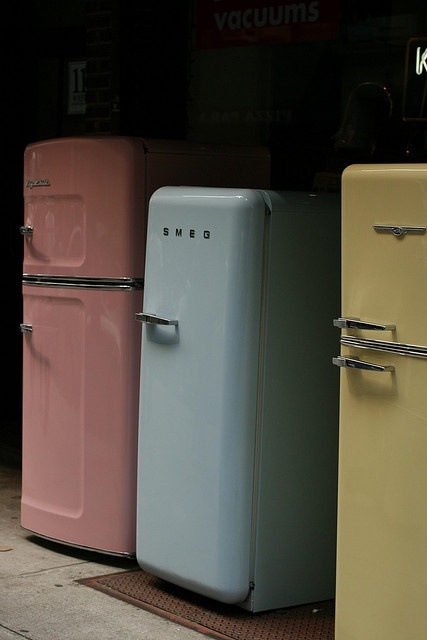Describe the objects in this image and their specific colors. I can see refrigerator in black and gray tones, refrigerator in black, brown, and maroon tones, and refrigerator in black and olive tones in this image. 